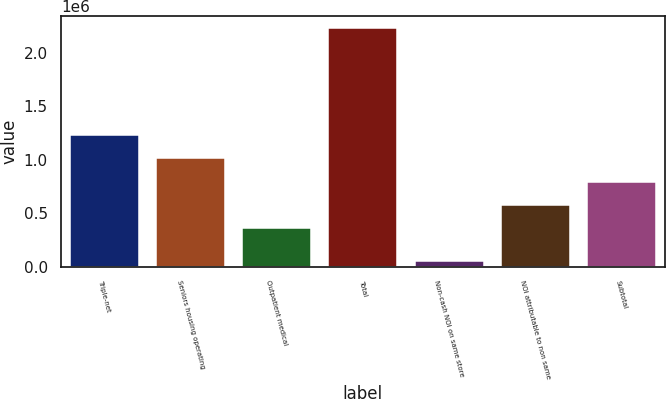<chart> <loc_0><loc_0><loc_500><loc_500><bar_chart><fcel>Triple-net<fcel>Seniors housing operating<fcel>Outpatient medical<fcel>Total<fcel>Non-cash NOI on same store<fcel>NOI attributable to non same<fcel>Subtotal<nl><fcel>1.23257e+06<fcel>1.01428e+06<fcel>359410<fcel>2.23648e+06<fcel>53578<fcel>577700<fcel>795990<nl></chart> 